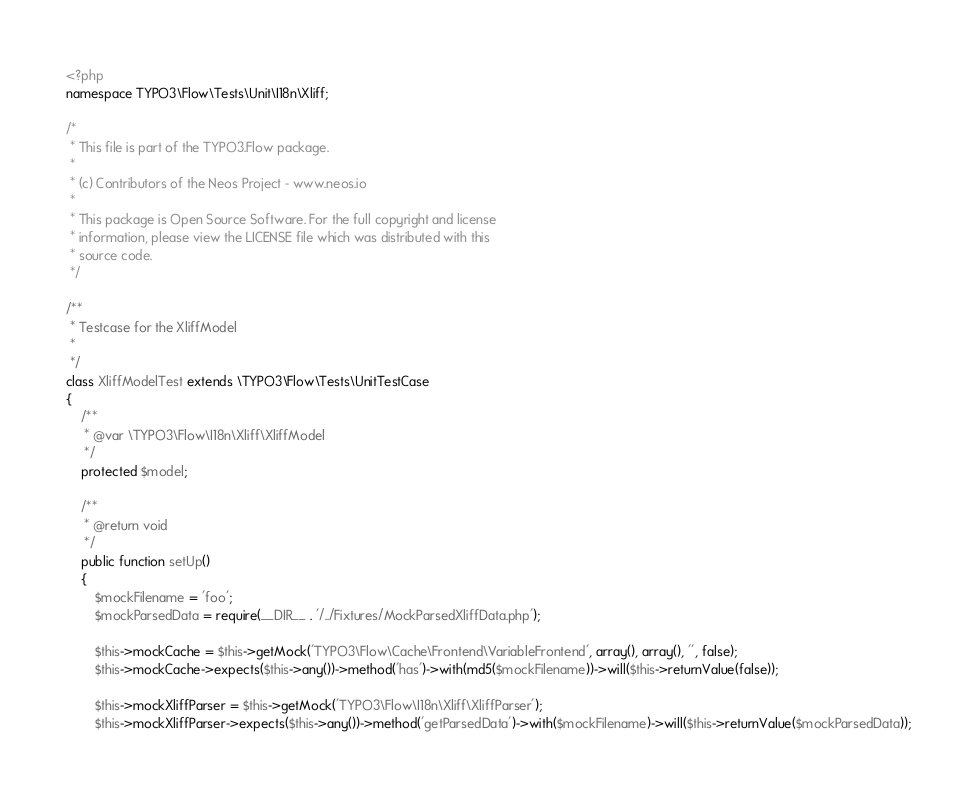<code> <loc_0><loc_0><loc_500><loc_500><_PHP_><?php
namespace TYPO3\Flow\Tests\Unit\I18n\Xliff;

/*
 * This file is part of the TYPO3.Flow package.
 *
 * (c) Contributors of the Neos Project - www.neos.io
 *
 * This package is Open Source Software. For the full copyright and license
 * information, please view the LICENSE file which was distributed with this
 * source code.
 */

/**
 * Testcase for the XliffModel
 *
 */
class XliffModelTest extends \TYPO3\Flow\Tests\UnitTestCase
{
    /**
     * @var \TYPO3\Flow\I18n\Xliff\XliffModel
     */
    protected $model;

    /**
     * @return void
     */
    public function setUp()
    {
        $mockFilename = 'foo';
        $mockParsedData = require(__DIR__ . '/../Fixtures/MockParsedXliffData.php');

        $this->mockCache = $this->getMock('TYPO3\Flow\Cache\Frontend\VariableFrontend', array(), array(), '', false);
        $this->mockCache->expects($this->any())->method('has')->with(md5($mockFilename))->will($this->returnValue(false));

        $this->mockXliffParser = $this->getMock('TYPO3\Flow\I18n\Xliff\XliffParser');
        $this->mockXliffParser->expects($this->any())->method('getParsedData')->with($mockFilename)->will($this->returnValue($mockParsedData));
</code> 